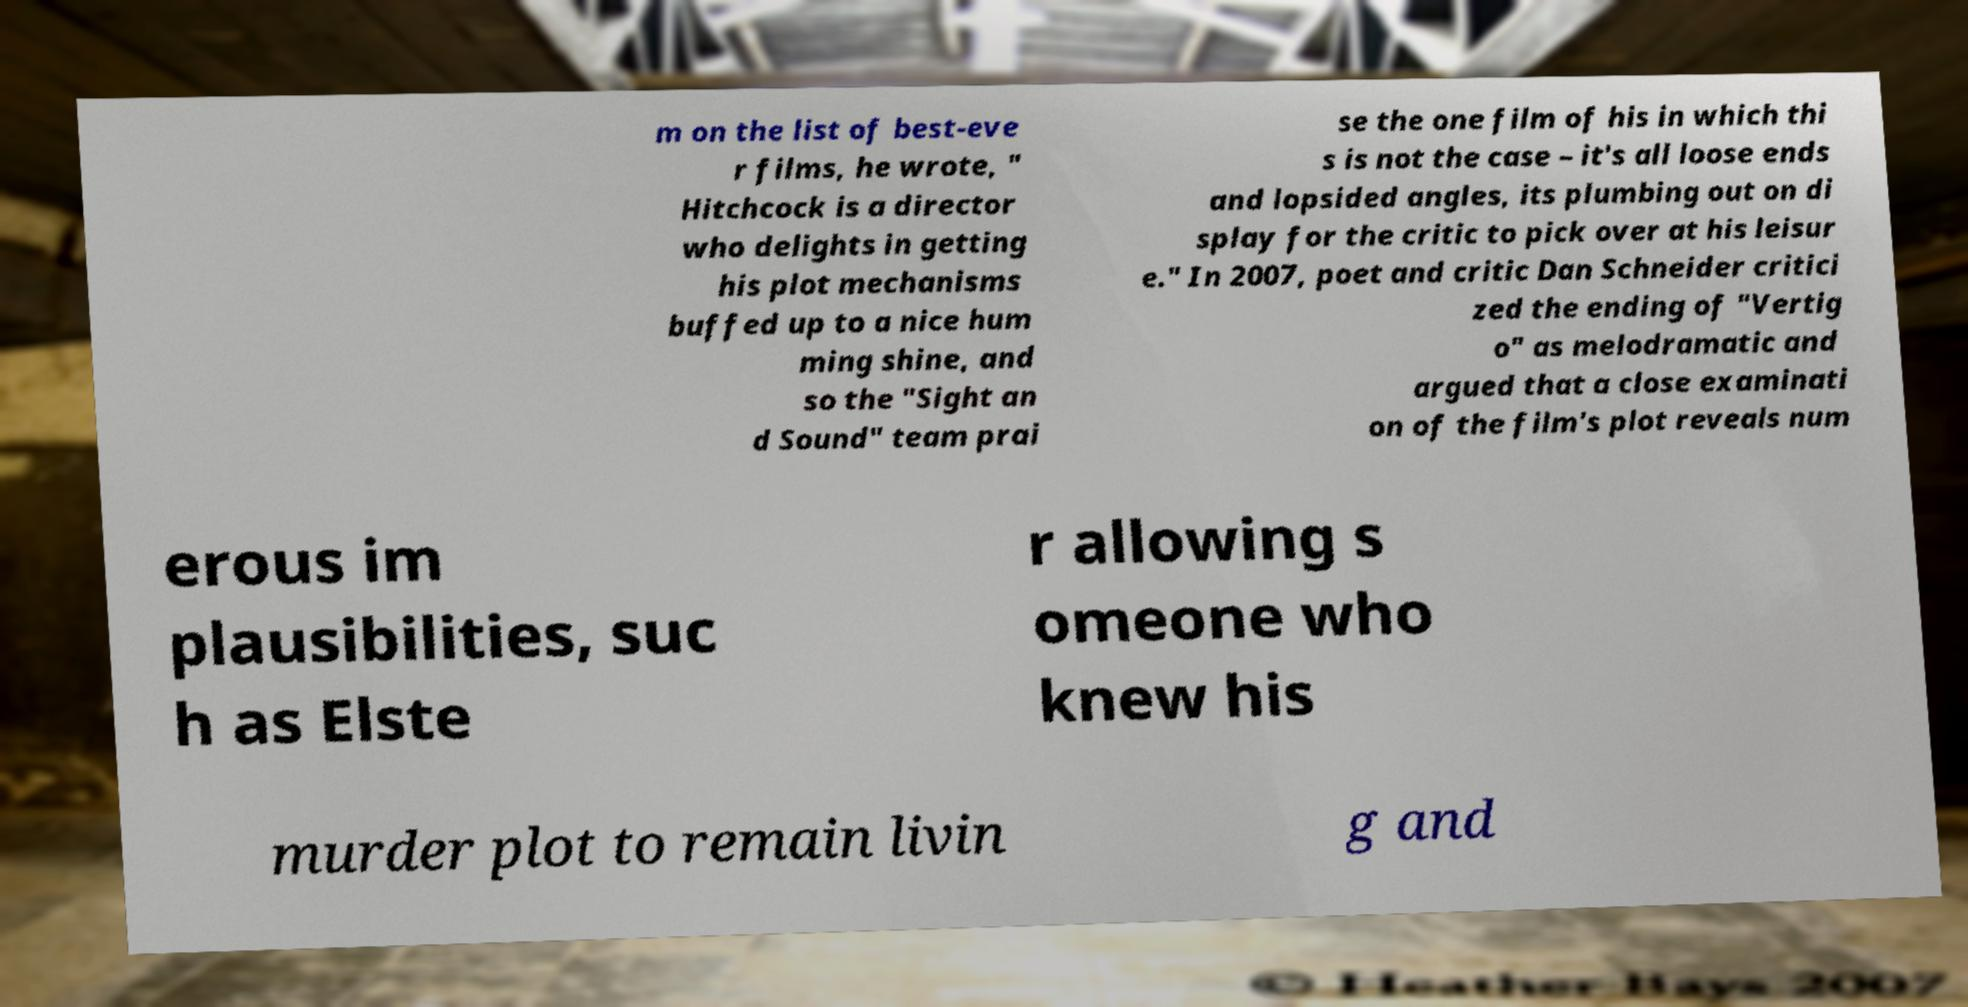Can you accurately transcribe the text from the provided image for me? m on the list of best-eve r films, he wrote, " Hitchcock is a director who delights in getting his plot mechanisms buffed up to a nice hum ming shine, and so the "Sight an d Sound" team prai se the one film of his in which thi s is not the case – it's all loose ends and lopsided angles, its plumbing out on di splay for the critic to pick over at his leisur e." In 2007, poet and critic Dan Schneider critici zed the ending of "Vertig o" as melodramatic and argued that a close examinati on of the film's plot reveals num erous im plausibilities, suc h as Elste r allowing s omeone who knew his murder plot to remain livin g and 